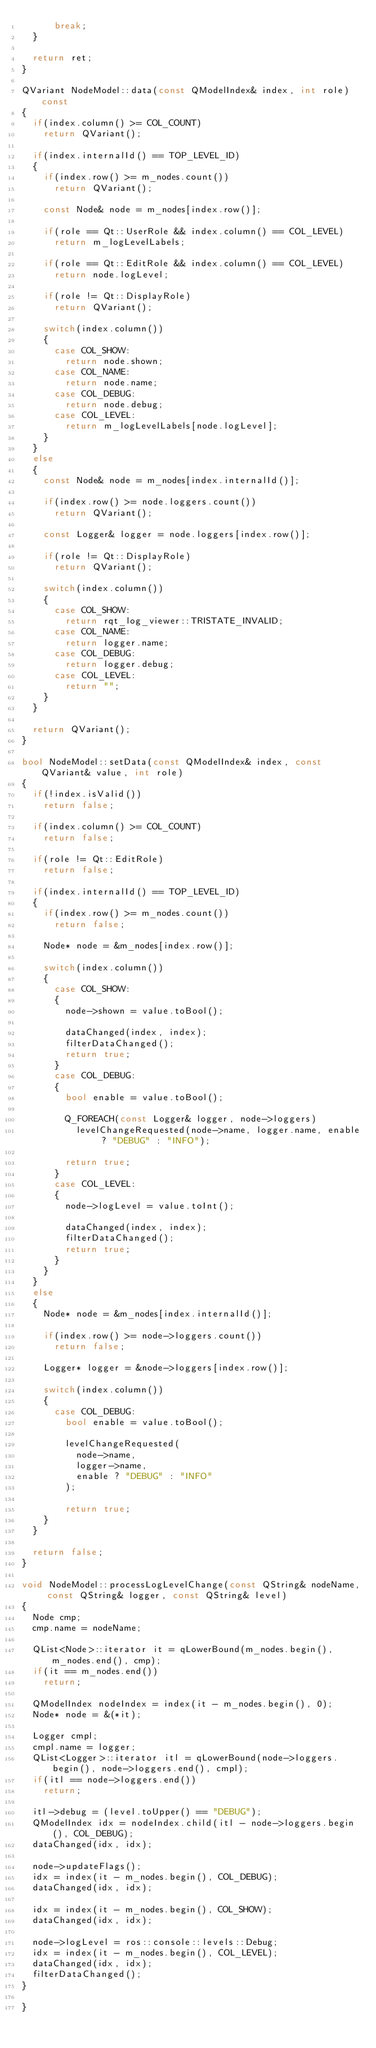Convert code to text. <code><loc_0><loc_0><loc_500><loc_500><_C++_>			break;
	}

	return ret;
}

QVariant NodeModel::data(const QModelIndex& index, int role) const
{
	if(index.column() >= COL_COUNT)
		return QVariant();

	if(index.internalId() == TOP_LEVEL_ID)
	{
		if(index.row() >= m_nodes.count())
			return QVariant();

		const Node& node = m_nodes[index.row()];

		if(role == Qt::UserRole && index.column() == COL_LEVEL)
			return m_logLevelLabels;

		if(role == Qt::EditRole && index.column() == COL_LEVEL)
			return node.logLevel;

		if(role != Qt::DisplayRole)
			return QVariant();

		switch(index.column())
		{
			case COL_SHOW:
				return node.shown;
			case COL_NAME:
				return node.name;
			case COL_DEBUG:
				return node.debug;
			case COL_LEVEL:
				return m_logLevelLabels[node.logLevel];
		}
	}
	else
	{
		const Node& node = m_nodes[index.internalId()];

		if(index.row() >= node.loggers.count())
			return QVariant();

		const Logger& logger = node.loggers[index.row()];

		if(role != Qt::DisplayRole)
			return QVariant();

		switch(index.column())
		{
			case COL_SHOW:
				return rqt_log_viewer::TRISTATE_INVALID;
			case COL_NAME:
				return logger.name;
			case COL_DEBUG:
				return logger.debug;
			case COL_LEVEL:
				return "";
		}
	}

	return QVariant();
}

bool NodeModel::setData(const QModelIndex& index, const QVariant& value, int role)
{
	if(!index.isValid())
		return false;

	if(index.column() >= COL_COUNT)
		return false;

	if(role != Qt::EditRole)
		return false;

	if(index.internalId() == TOP_LEVEL_ID)
	{
		if(index.row() >= m_nodes.count())
			return false;

		Node* node = &m_nodes[index.row()];

		switch(index.column())
		{
			case COL_SHOW:
			{
				node->shown = value.toBool();

				dataChanged(index, index);
				filterDataChanged();
				return true;
			}
			case COL_DEBUG:
			{
				bool enable = value.toBool();

				Q_FOREACH(const Logger& logger, node->loggers)
					levelChangeRequested(node->name, logger.name, enable ? "DEBUG" : "INFO");

				return true;
			}
			case COL_LEVEL:
			{
				node->logLevel = value.toInt();

				dataChanged(index, index);
				filterDataChanged();
				return true;
			}
		}
	}
	else
	{
		Node* node = &m_nodes[index.internalId()];

		if(index.row() >= node->loggers.count())
			return false;

		Logger* logger = &node->loggers[index.row()];

		switch(index.column())
		{
			case COL_DEBUG:
				bool enable = value.toBool();

				levelChangeRequested(
					node->name,
					logger->name,
					enable ? "DEBUG" : "INFO"
				);

				return true;
		}
	}

	return false;
}

void NodeModel::processLogLevelChange(const QString& nodeName, const QString& logger, const QString& level)
{
	Node cmp;
	cmp.name = nodeName;

	QList<Node>::iterator it = qLowerBound(m_nodes.begin(), m_nodes.end(), cmp);
	if(it == m_nodes.end())
		return;

	QModelIndex nodeIndex = index(it - m_nodes.begin(), 0);
	Node* node = &(*it);

	Logger cmpl;
	cmpl.name = logger;
	QList<Logger>::iterator itl = qLowerBound(node->loggers.begin(), node->loggers.end(), cmpl);
	if(itl == node->loggers.end())
		return;

	itl->debug = (level.toUpper() == "DEBUG");
	QModelIndex idx = nodeIndex.child(itl - node->loggers.begin(), COL_DEBUG);
	dataChanged(idx, idx);

	node->updateFlags();
	idx = index(it - m_nodes.begin(), COL_DEBUG);
	dataChanged(idx, idx);

	idx = index(it - m_nodes.begin(), COL_SHOW);
	dataChanged(idx, idx);

	node->logLevel = ros::console::levels::Debug;
	idx = index(it - m_nodes.begin(), COL_LEVEL);
	dataChanged(idx, idx);
	filterDataChanged();
}

}
</code> 